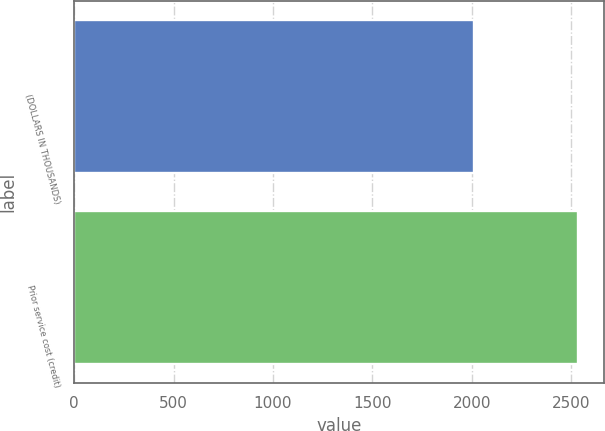Convert chart. <chart><loc_0><loc_0><loc_500><loc_500><bar_chart><fcel>(DOLLARS IN THOUSANDS)<fcel>Prior service cost (credit)<nl><fcel>2009<fcel>2536<nl></chart> 